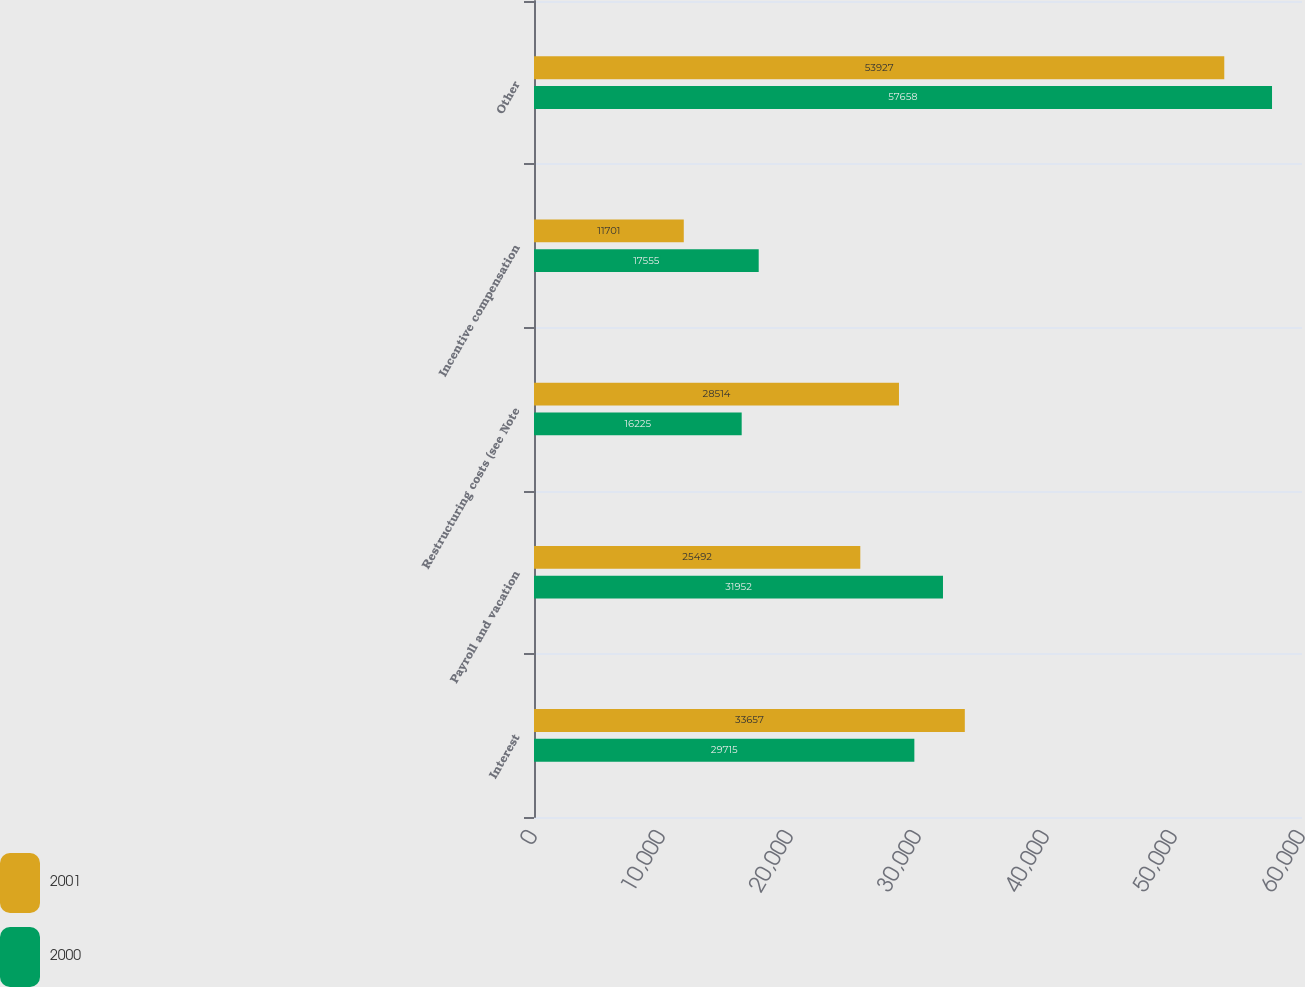<chart> <loc_0><loc_0><loc_500><loc_500><stacked_bar_chart><ecel><fcel>Interest<fcel>Payroll and vacation<fcel>Restructuring costs (see Note<fcel>Incentive compensation<fcel>Other<nl><fcel>2001<fcel>33657<fcel>25492<fcel>28514<fcel>11701<fcel>53927<nl><fcel>2000<fcel>29715<fcel>31952<fcel>16225<fcel>17555<fcel>57658<nl></chart> 